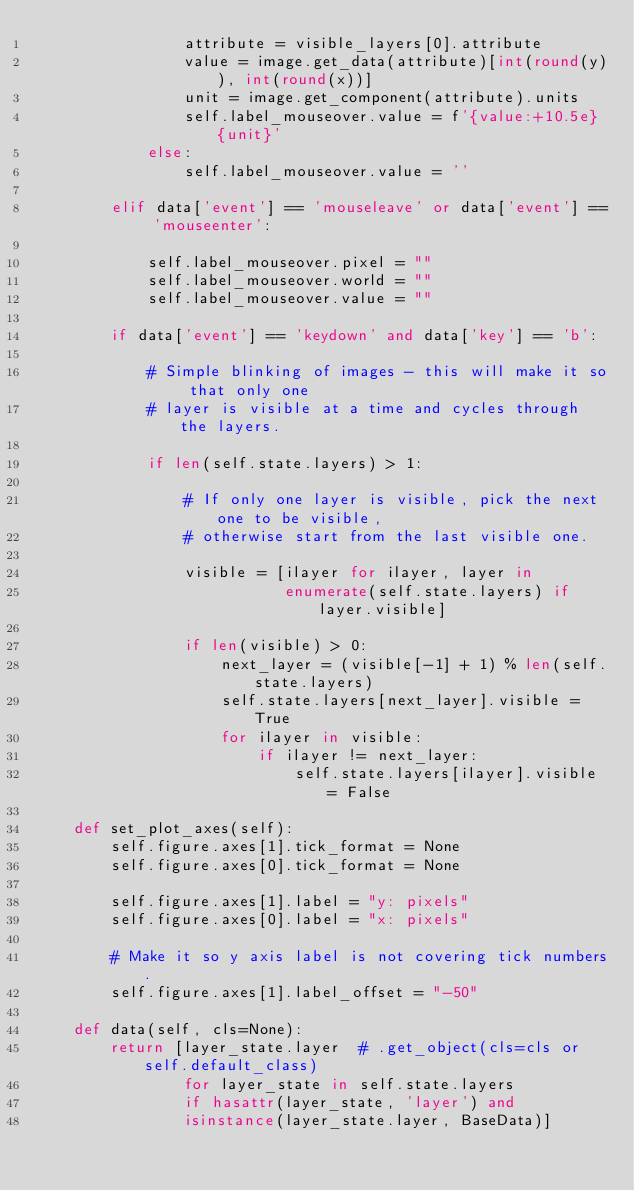<code> <loc_0><loc_0><loc_500><loc_500><_Python_>                attribute = visible_layers[0].attribute
                value = image.get_data(attribute)[int(round(y)), int(round(x))]
                unit = image.get_component(attribute).units
                self.label_mouseover.value = f'{value:+10.5e} {unit}'
            else:
                self.label_mouseover.value = ''

        elif data['event'] == 'mouseleave' or data['event'] == 'mouseenter':

            self.label_mouseover.pixel = ""
            self.label_mouseover.world = ""
            self.label_mouseover.value = ""

        if data['event'] == 'keydown' and data['key'] == 'b':

            # Simple blinking of images - this will make it so that only one
            # layer is visible at a time and cycles through the layers.

            if len(self.state.layers) > 1:

                # If only one layer is visible, pick the next one to be visible,
                # otherwise start from the last visible one.

                visible = [ilayer for ilayer, layer in
                           enumerate(self.state.layers) if layer.visible]

                if len(visible) > 0:
                    next_layer = (visible[-1] + 1) % len(self.state.layers)
                    self.state.layers[next_layer].visible = True
                    for ilayer in visible:
                        if ilayer != next_layer:
                            self.state.layers[ilayer].visible = False

    def set_plot_axes(self):
        self.figure.axes[1].tick_format = None
        self.figure.axes[0].tick_format = None

        self.figure.axes[1].label = "y: pixels"
        self.figure.axes[0].label = "x: pixels"

        # Make it so y axis label is not covering tick numbers.
        self.figure.axes[1].label_offset = "-50"

    def data(self, cls=None):
        return [layer_state.layer  # .get_object(cls=cls or self.default_class)
                for layer_state in self.state.layers
                if hasattr(layer_state, 'layer') and
                isinstance(layer_state.layer, BaseData)]
</code> 